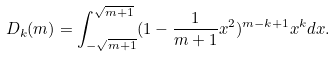Convert formula to latex. <formula><loc_0><loc_0><loc_500><loc_500>D _ { k } ( m ) = \int _ { - \sqrt { m + 1 } } ^ { \sqrt { m + 1 } } ( 1 - \frac { 1 } { m + 1 } x ^ { 2 } ) ^ { m - k + 1 } x ^ { k } d x .</formula> 